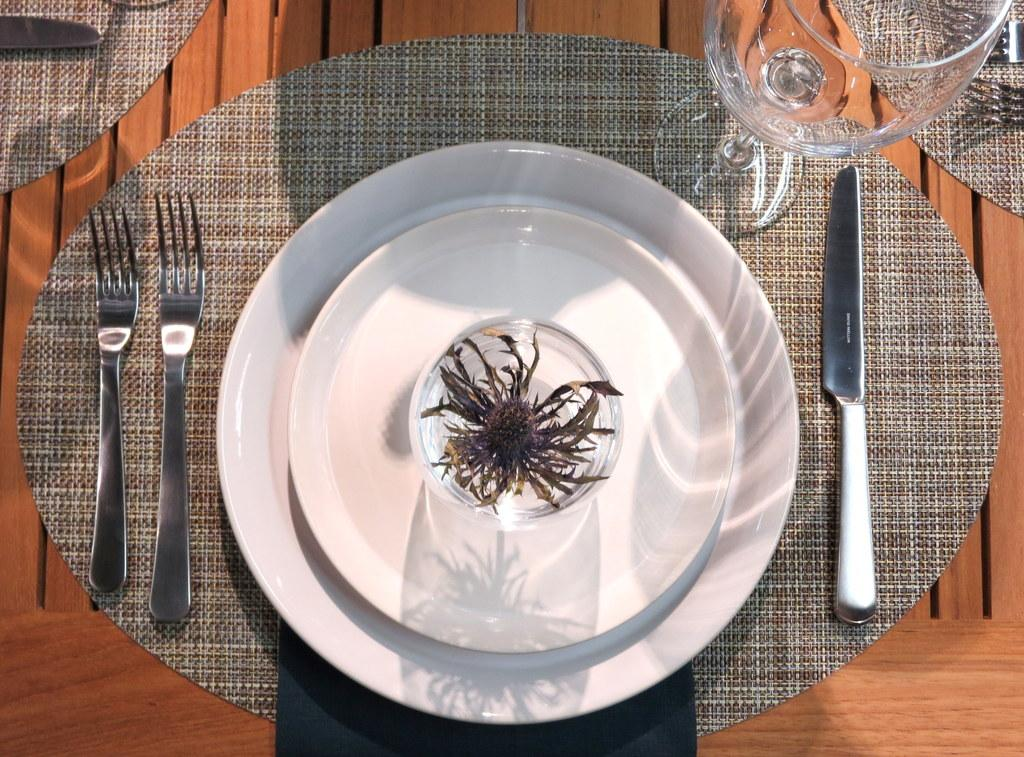What type of furniture is present in the image? There is a table in the image. What items are placed on the table? There are doormats, cutlery, serving plates, a paper weight, and a wine glass on the table. What might be used for eating or serving food in the image? Cutlery and serving plates are present on the table. What is used for holding down papers in the image? There is a paper weight on the table. What type of roof can be seen on the house in the image? There is no house or roof present in the image; it only features a table with various items on it. 